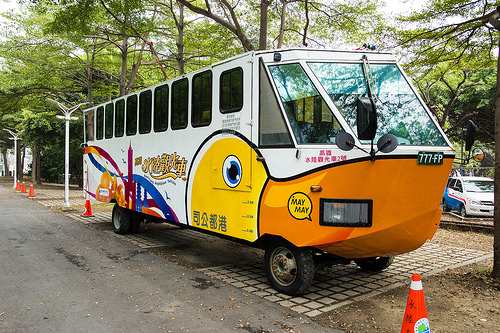<image>
Can you confirm if the bus is under the tree? Yes. The bus is positioned underneath the tree, with the tree above it in the vertical space. 